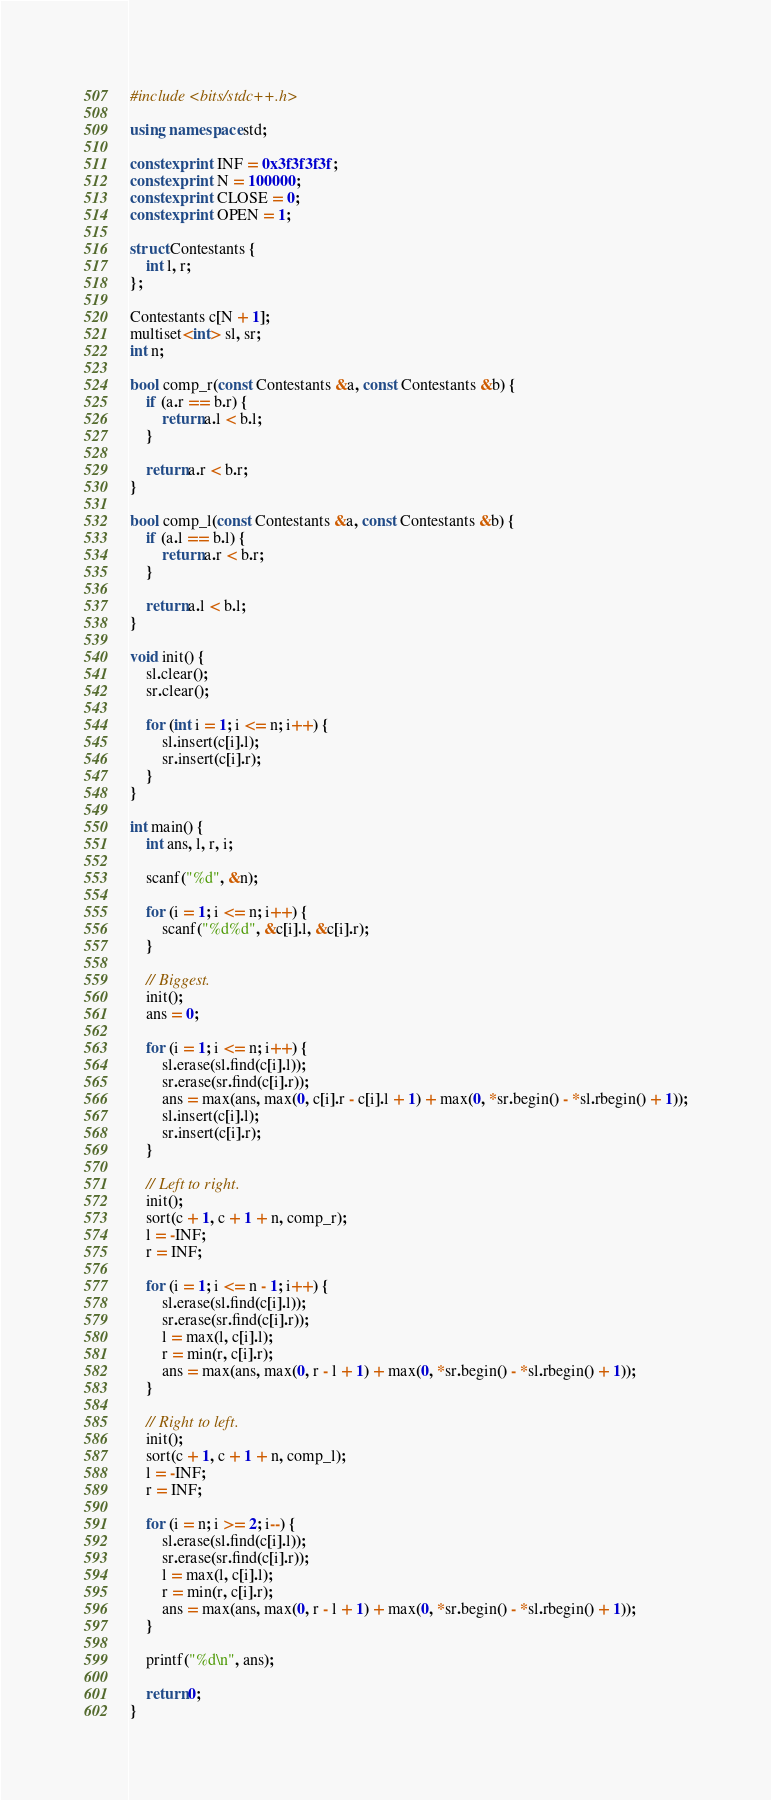Convert code to text. <code><loc_0><loc_0><loc_500><loc_500><_C++_>#include <bits/stdc++.h>

using namespace std;

constexpr int INF = 0x3f3f3f3f;
constexpr int N = 100000;
constexpr int CLOSE = 0;
constexpr int OPEN = 1;

struct Contestants {
	int l, r;
};

Contestants c[N + 1];
multiset<int> sl, sr;
int n;

bool comp_r(const Contestants &a, const Contestants &b) {
	if (a.r == b.r) {
		return a.l < b.l;
	}

	return a.r < b.r;
}

bool comp_l(const Contestants &a, const Contestants &b) {
	if (a.l == b.l) {
		return a.r < b.r;
	}

	return a.l < b.l;
}

void init() {
	sl.clear();
	sr.clear();

	for (int i = 1; i <= n; i++) {
		sl.insert(c[i].l);
		sr.insert(c[i].r);
	}
}

int main() {
	int ans, l, r, i;

	scanf("%d", &n);

	for (i = 1; i <= n; i++) {
		scanf("%d%d", &c[i].l, &c[i].r);
	}

	// Biggest.
	init();
	ans = 0;

	for (i = 1; i <= n; i++) {
		sl.erase(sl.find(c[i].l));
		sr.erase(sr.find(c[i].r));
		ans = max(ans, max(0, c[i].r - c[i].l + 1) + max(0, *sr.begin() - *sl.rbegin() + 1));
		sl.insert(c[i].l);
		sr.insert(c[i].r);
	}

	// Left to right.
	init();
	sort(c + 1, c + 1 + n, comp_r);
	l = -INF;
	r = INF;

	for (i = 1; i <= n - 1; i++) {
		sl.erase(sl.find(c[i].l));
		sr.erase(sr.find(c[i].r));
		l = max(l, c[i].l);
		r = min(r, c[i].r);
		ans = max(ans, max(0, r - l + 1) + max(0, *sr.begin() - *sl.rbegin() + 1));
	}

	// Right to left.
	init();
	sort(c + 1, c + 1 + n, comp_l);
	l = -INF;
	r = INF;

	for (i = n; i >= 2; i--) {
		sl.erase(sl.find(c[i].l));
		sr.erase(sr.find(c[i].r));
		l = max(l, c[i].l);
		r = min(r, c[i].r);
		ans = max(ans, max(0, r - l + 1) + max(0, *sr.begin() - *sl.rbegin() + 1));
	}

	printf("%d\n", ans);

	return 0;
}</code> 